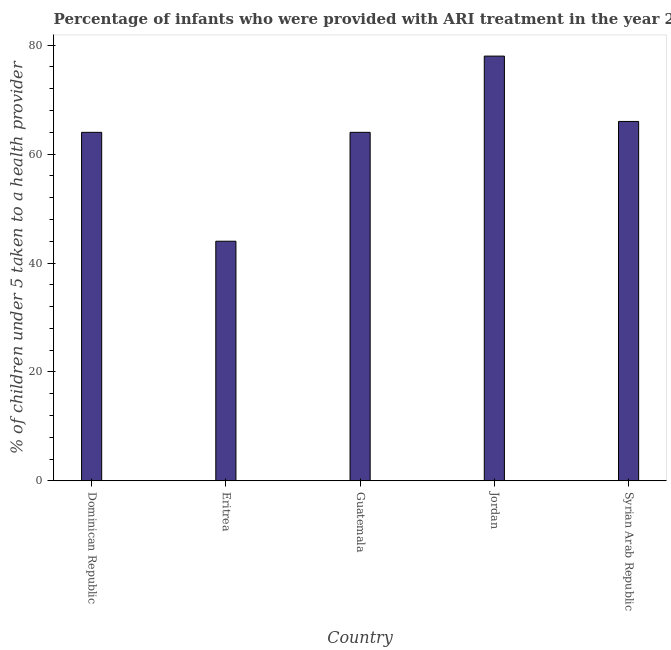Does the graph contain any zero values?
Provide a short and direct response. No. What is the title of the graph?
Offer a terse response. Percentage of infants who were provided with ARI treatment in the year 2002. What is the label or title of the Y-axis?
Your answer should be very brief. % of children under 5 taken to a health provider. What is the percentage of children who were provided with ari treatment in Guatemala?
Offer a very short reply. 64. Across all countries, what is the minimum percentage of children who were provided with ari treatment?
Offer a very short reply. 44. In which country was the percentage of children who were provided with ari treatment maximum?
Keep it short and to the point. Jordan. In which country was the percentage of children who were provided with ari treatment minimum?
Provide a short and direct response. Eritrea. What is the sum of the percentage of children who were provided with ari treatment?
Make the answer very short. 316. What is the median percentage of children who were provided with ari treatment?
Give a very brief answer. 64. In how many countries, is the percentage of children who were provided with ari treatment greater than 36 %?
Offer a terse response. 5. What is the ratio of the percentage of children who were provided with ari treatment in Eritrea to that in Jordan?
Ensure brevity in your answer.  0.56. Is the percentage of children who were provided with ari treatment in Dominican Republic less than that in Eritrea?
Offer a very short reply. No. Is the difference between the percentage of children who were provided with ari treatment in Dominican Republic and Guatemala greater than the difference between any two countries?
Your answer should be compact. No. How many countries are there in the graph?
Offer a very short reply. 5. What is the difference between two consecutive major ticks on the Y-axis?
Give a very brief answer. 20. What is the % of children under 5 taken to a health provider of Guatemala?
Provide a succinct answer. 64. What is the % of children under 5 taken to a health provider of Jordan?
Make the answer very short. 78. What is the difference between the % of children under 5 taken to a health provider in Dominican Republic and Eritrea?
Your answer should be compact. 20. What is the difference between the % of children under 5 taken to a health provider in Dominican Republic and Guatemala?
Offer a terse response. 0. What is the difference between the % of children under 5 taken to a health provider in Dominican Republic and Syrian Arab Republic?
Offer a very short reply. -2. What is the difference between the % of children under 5 taken to a health provider in Eritrea and Jordan?
Provide a succinct answer. -34. What is the difference between the % of children under 5 taken to a health provider in Eritrea and Syrian Arab Republic?
Offer a terse response. -22. What is the ratio of the % of children under 5 taken to a health provider in Dominican Republic to that in Eritrea?
Make the answer very short. 1.46. What is the ratio of the % of children under 5 taken to a health provider in Dominican Republic to that in Jordan?
Keep it short and to the point. 0.82. What is the ratio of the % of children under 5 taken to a health provider in Dominican Republic to that in Syrian Arab Republic?
Offer a very short reply. 0.97. What is the ratio of the % of children under 5 taken to a health provider in Eritrea to that in Guatemala?
Keep it short and to the point. 0.69. What is the ratio of the % of children under 5 taken to a health provider in Eritrea to that in Jordan?
Your response must be concise. 0.56. What is the ratio of the % of children under 5 taken to a health provider in Eritrea to that in Syrian Arab Republic?
Provide a succinct answer. 0.67. What is the ratio of the % of children under 5 taken to a health provider in Guatemala to that in Jordan?
Your answer should be very brief. 0.82. What is the ratio of the % of children under 5 taken to a health provider in Guatemala to that in Syrian Arab Republic?
Keep it short and to the point. 0.97. What is the ratio of the % of children under 5 taken to a health provider in Jordan to that in Syrian Arab Republic?
Give a very brief answer. 1.18. 